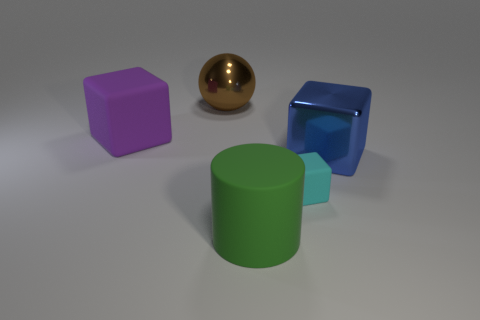What color is the ball that is the same size as the green thing?
Your answer should be compact. Brown. What color is the block that is both left of the big blue metal object and on the right side of the purple block?
Your response must be concise. Cyan. Is the number of big blue objects behind the small cyan block greater than the number of cyan rubber blocks that are on the left side of the big brown metallic object?
Provide a succinct answer. Yes. There is a green cylinder that is made of the same material as the large purple thing; what is its size?
Ensure brevity in your answer.  Large. What number of big purple rubber things are on the left side of the rubber thing on the left side of the rubber cylinder?
Provide a succinct answer. 0. Is there a small cyan rubber object of the same shape as the green thing?
Your answer should be very brief. No. There is a thing behind the rubber cube left of the large green rubber object; what color is it?
Your answer should be compact. Brown. Is the number of rubber blocks greater than the number of big green matte cylinders?
Make the answer very short. Yes. What number of yellow matte objects have the same size as the rubber cylinder?
Offer a terse response. 0. Is the material of the sphere the same as the large object that is on the left side of the big brown shiny thing?
Provide a succinct answer. No. 